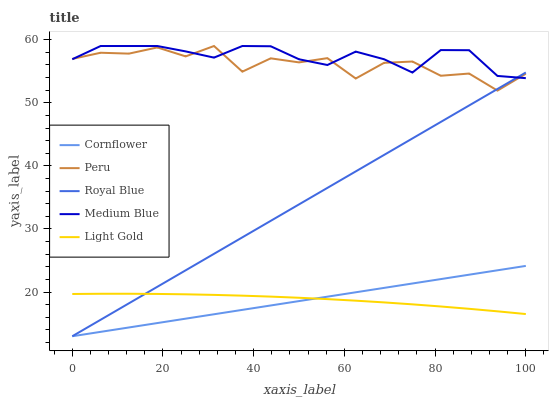Does Cornflower have the minimum area under the curve?
Answer yes or no. Yes. Does Medium Blue have the maximum area under the curve?
Answer yes or no. Yes. Does Light Gold have the minimum area under the curve?
Answer yes or no. No. Does Light Gold have the maximum area under the curve?
Answer yes or no. No. Is Cornflower the smoothest?
Answer yes or no. Yes. Is Peru the roughest?
Answer yes or no. Yes. Is Light Gold the smoothest?
Answer yes or no. No. Is Light Gold the roughest?
Answer yes or no. No. Does Cornflower have the lowest value?
Answer yes or no. Yes. Does Light Gold have the lowest value?
Answer yes or no. No. Does Peru have the highest value?
Answer yes or no. Yes. Does Light Gold have the highest value?
Answer yes or no. No. Is Light Gold less than Medium Blue?
Answer yes or no. Yes. Is Medium Blue greater than Cornflower?
Answer yes or no. Yes. Does Peru intersect Royal Blue?
Answer yes or no. Yes. Is Peru less than Royal Blue?
Answer yes or no. No. Is Peru greater than Royal Blue?
Answer yes or no. No. Does Light Gold intersect Medium Blue?
Answer yes or no. No. 